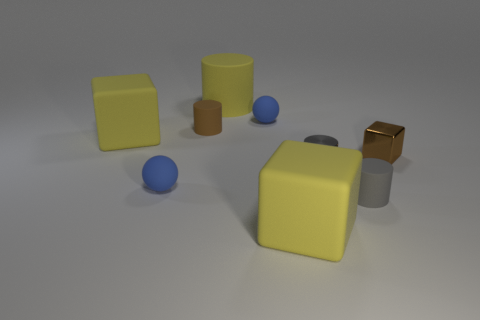What does the arrangement of objects in this image suggest about the lighting and shadows? The objects in the image cast soft-edged shadows towards the left, which indicates that the light source is situated off to the right-hand side of the scene. The muted nature of the shadows suggests diffused lighting, possibly from an overcast sky or a soft light in a studio setting. 